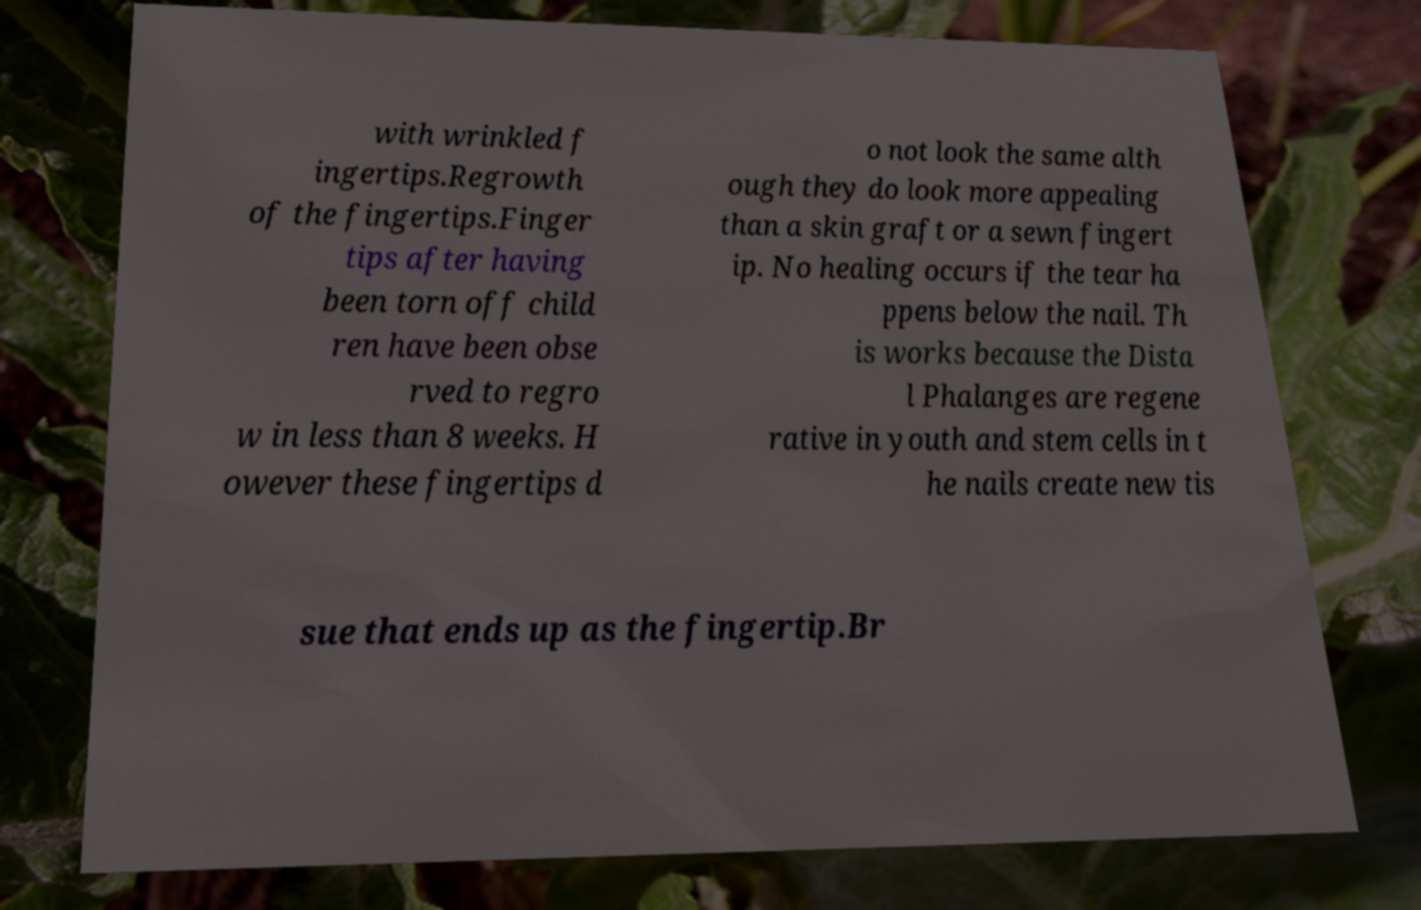I need the written content from this picture converted into text. Can you do that? with wrinkled f ingertips.Regrowth of the fingertips.Finger tips after having been torn off child ren have been obse rved to regro w in less than 8 weeks. H owever these fingertips d o not look the same alth ough they do look more appealing than a skin graft or a sewn fingert ip. No healing occurs if the tear ha ppens below the nail. Th is works because the Dista l Phalanges are regene rative in youth and stem cells in t he nails create new tis sue that ends up as the fingertip.Br 